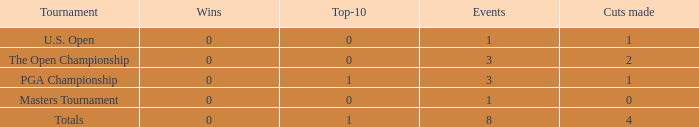For more than 3 events in the PGA Championship, what is the fewest number of wins? None. 